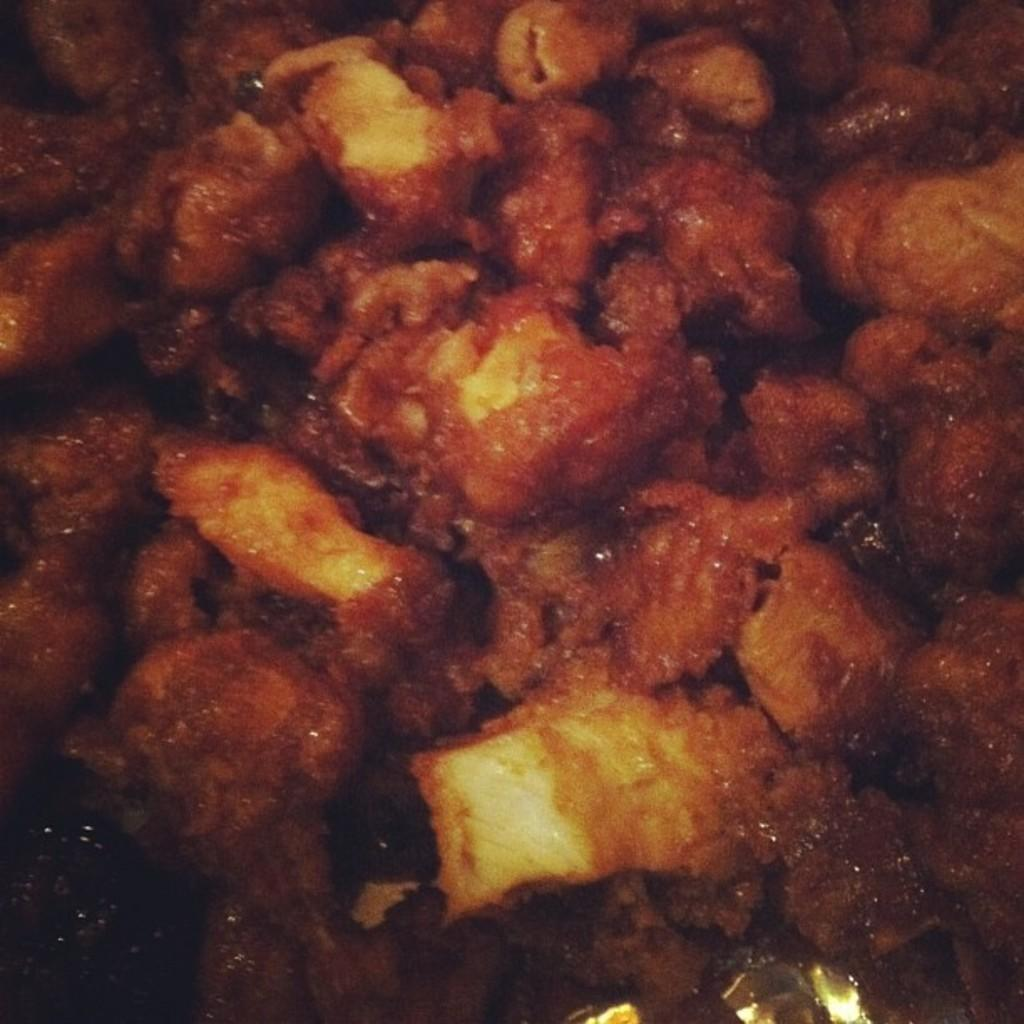What can be seen in the image related to food? There is some food visible in the image. How many crows are sitting on the tub in the image? There are no crows or tubs present in the image. 